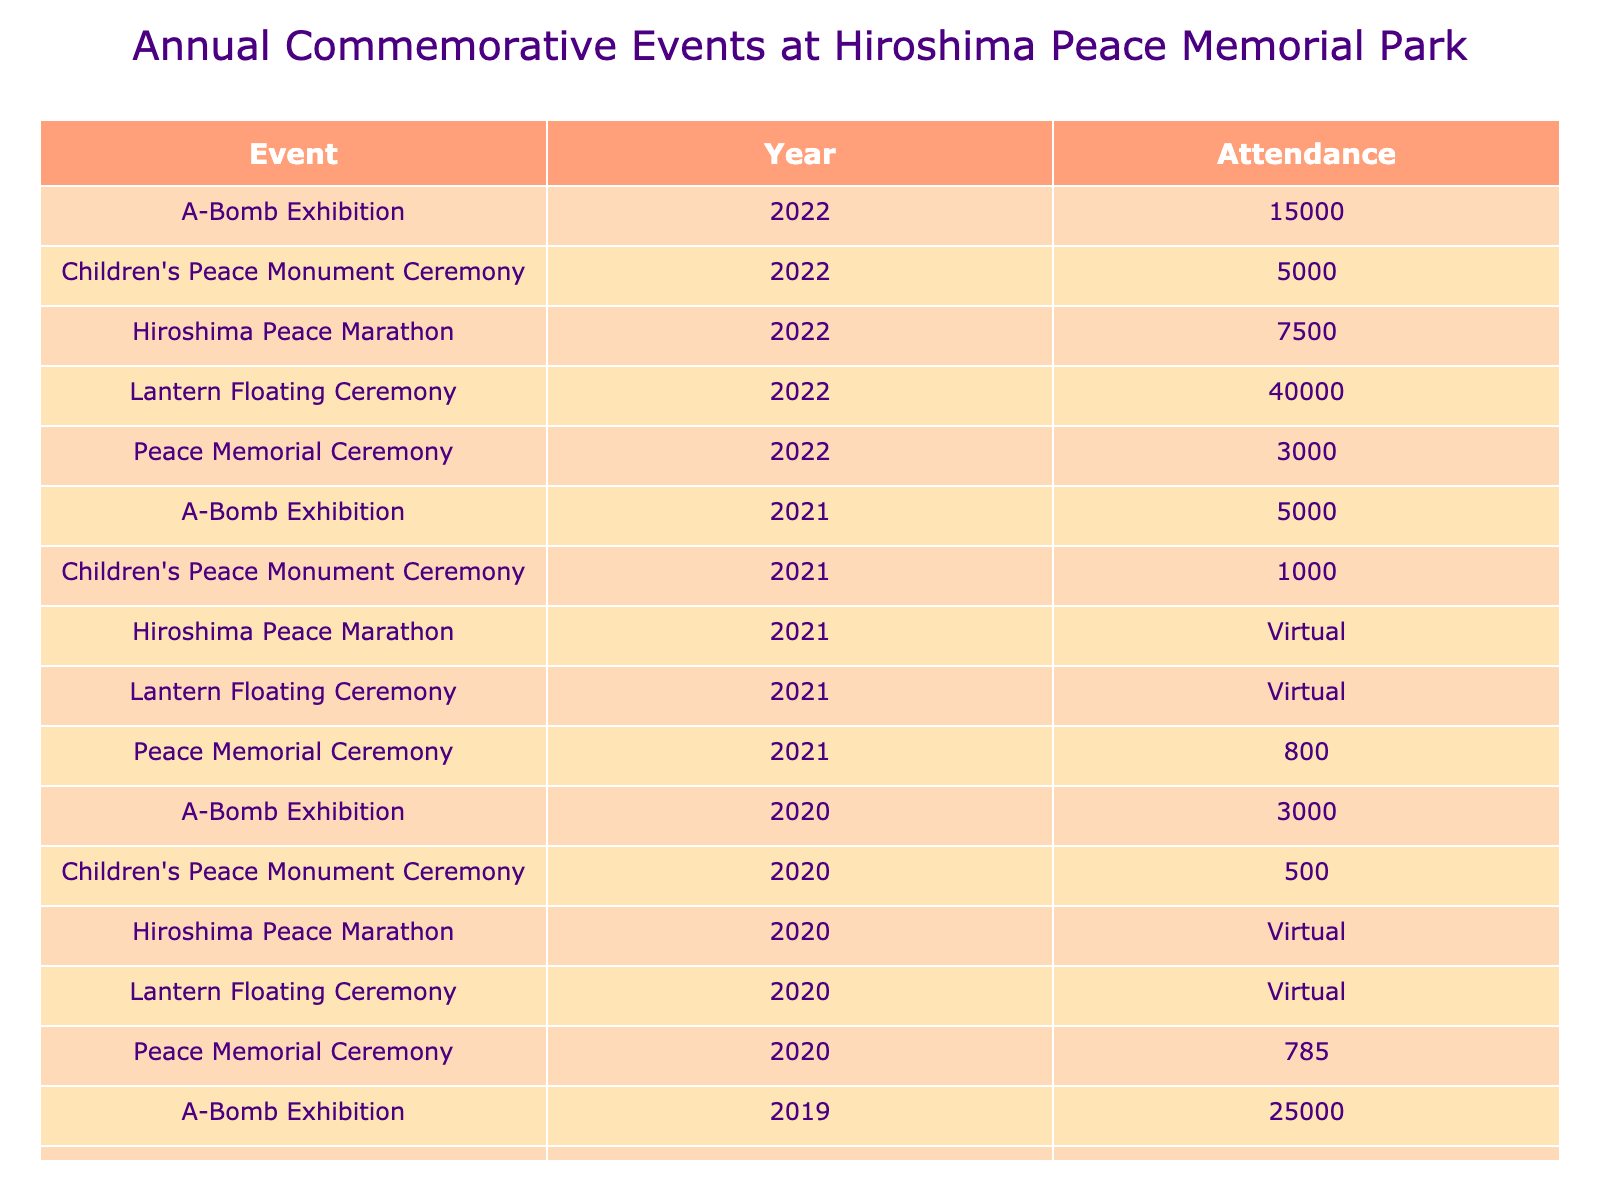What was the attendance for the Peace Memorial Ceremony in 2022? The table indicates that the attendance for the Peace Memorial Ceremony in 2022 was 3000.
Answer: 3000 How many people attended the Lantern Floating Ceremony in 2019? According to the table, the Lantern Floating Ceremony in 2019 had an attendance of 65000.
Answer: 65000 In what year did the Hiroshima Peace Marathon have the highest attendance? Looking at the attendance for the Hiroshima Peace Marathon, the highest attendance occurred in 2019 with 10000 attendees.
Answer: 2019 What was the total attendance for all events in 2022? By summing the individual attendances for each event in 2022 (3000 + 40000 + 15000 + 7500 + 5000), the total attendance equals 62500.
Answer: 62500 How many events had an attendance listed as "Cancelled" over the years? There were two events listed as "Cancelled": the Hiroshima Peace Marathon in 2021 and 2020, making the total count 2.
Answer: 2 Was attendance for the A-Bomb Exhibition higher in 2019 or 2022? Comparing the A-Bomb Exhibition attendance, 2019 had 25000 attendees while 2022 had 15000 attendees; thus, 2019 had the higher attendance.
Answer: 2019 What was the average attendance for the Children's Peace Monument Ceremony across all years? The attendance figures are 5000 (2022), 1000 (2021), 500 (2020), and 8000 (2019). Adding these (5000 + 1000 + 500 + 8000) gives 13500. Dividing by the number of years (4) results in an average attendance of 3375.
Answer: 3375 How many more attendees attended the Lantern Floating Ceremony in 2019 compared to 2021? The attendance for the Lantern Floating Ceremony in 2019 was 65000 and in 2021 it was 'Virtual' (considered as 0 for counting). The difference is 65000 - 0 = 65000.
Answer: 65000 Was there an increase or decrease in attendance for the Peace Memorial Ceremony from 2021 to 2022? In 2021, the attendance for the Peace Memorial Ceremony was 800, and in 2022 it was 3000. Comparing these figures, there was an increase of 2200 attendees.
Answer: Increase 